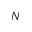Convert formula to latex. <formula><loc_0><loc_0><loc_500><loc_500>N</formula> 